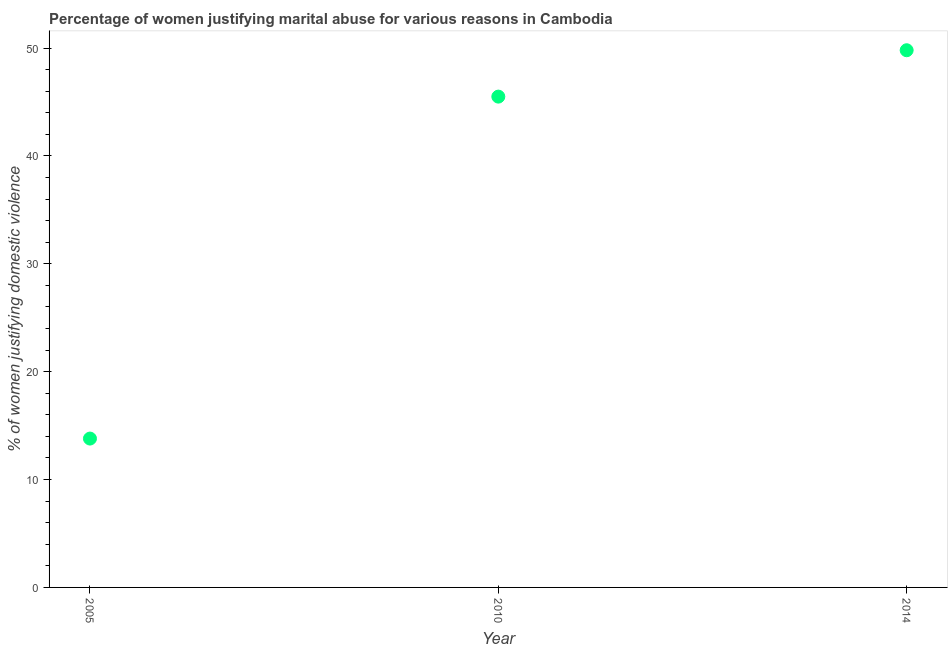What is the percentage of women justifying marital abuse in 2014?
Your response must be concise. 49.8. Across all years, what is the maximum percentage of women justifying marital abuse?
Provide a short and direct response. 49.8. In which year was the percentage of women justifying marital abuse minimum?
Your response must be concise. 2005. What is the sum of the percentage of women justifying marital abuse?
Your answer should be compact. 109.1. What is the difference between the percentage of women justifying marital abuse in 2005 and 2014?
Your answer should be very brief. -36. What is the average percentage of women justifying marital abuse per year?
Your answer should be very brief. 36.37. What is the median percentage of women justifying marital abuse?
Make the answer very short. 45.5. In how many years, is the percentage of women justifying marital abuse greater than 44 %?
Provide a short and direct response. 2. Do a majority of the years between 2014 and 2010 (inclusive) have percentage of women justifying marital abuse greater than 36 %?
Provide a succinct answer. No. What is the ratio of the percentage of women justifying marital abuse in 2010 to that in 2014?
Ensure brevity in your answer.  0.91. What is the difference between the highest and the second highest percentage of women justifying marital abuse?
Your answer should be compact. 4.3. What is the difference between the highest and the lowest percentage of women justifying marital abuse?
Keep it short and to the point. 36. In how many years, is the percentage of women justifying marital abuse greater than the average percentage of women justifying marital abuse taken over all years?
Provide a short and direct response. 2. Does the percentage of women justifying marital abuse monotonically increase over the years?
Offer a terse response. Yes. How many dotlines are there?
Make the answer very short. 1. What is the difference between two consecutive major ticks on the Y-axis?
Your answer should be very brief. 10. Are the values on the major ticks of Y-axis written in scientific E-notation?
Your answer should be compact. No. Does the graph contain grids?
Provide a short and direct response. No. What is the title of the graph?
Provide a short and direct response. Percentage of women justifying marital abuse for various reasons in Cambodia. What is the label or title of the X-axis?
Your answer should be compact. Year. What is the label or title of the Y-axis?
Offer a terse response. % of women justifying domestic violence. What is the % of women justifying domestic violence in 2010?
Offer a terse response. 45.5. What is the % of women justifying domestic violence in 2014?
Make the answer very short. 49.8. What is the difference between the % of women justifying domestic violence in 2005 and 2010?
Your answer should be very brief. -31.7. What is the difference between the % of women justifying domestic violence in 2005 and 2014?
Your answer should be very brief. -36. What is the ratio of the % of women justifying domestic violence in 2005 to that in 2010?
Provide a short and direct response. 0.3. What is the ratio of the % of women justifying domestic violence in 2005 to that in 2014?
Offer a terse response. 0.28. What is the ratio of the % of women justifying domestic violence in 2010 to that in 2014?
Provide a short and direct response. 0.91. 